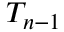<formula> <loc_0><loc_0><loc_500><loc_500>T _ { n - 1 }</formula> 